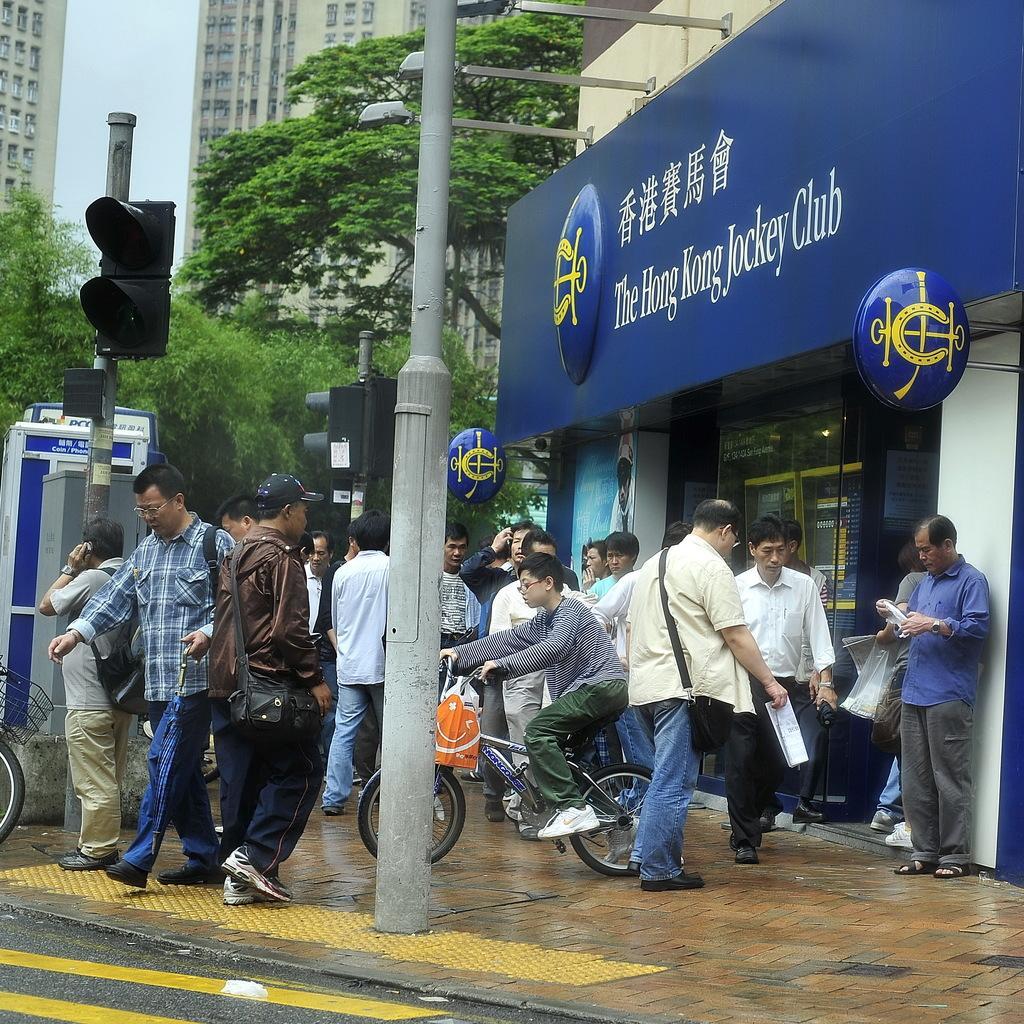Could you give a brief overview of what you see in this image? In the center of the image we can see a pole and a boy is riding a bicycle and carrying a bag. In the background of the image we can see the buildings, trees, poles, traffic lights, lights, board, door and some people are standing and some of them are walking on the pavement and some of them are carrying bags and holding papers. At the bottom of the image we can see the road. In the top left corner we can see the sky. 